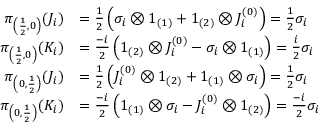<formula> <loc_0><loc_0><loc_500><loc_500>{ \begin{array} { r l } { \pi _ { \left ( { \frac { 1 } { 2 } } , 0 \right ) } ( J _ { i } ) } & { = { \frac { 1 } { 2 } } \left ( \sigma _ { i } \otimes 1 _ { ( 1 ) } + 1 _ { ( 2 ) } \otimes J _ { i } ^ { ( 0 ) } \right ) = { \frac { 1 } { 2 } } \sigma _ { i } } \\ { \pi _ { \left ( { \frac { 1 } { 2 } } , 0 \right ) } ( K _ { i } ) } & { = { \frac { - i } { 2 } } \left ( 1 _ { ( 2 ) } \otimes J _ { i } ^ { ( 0 ) } - \sigma _ { i } \otimes 1 _ { ( 1 ) } \right ) = { \frac { i } { 2 } } \sigma _ { i } } \\ { \pi _ { \left ( 0 , { \frac { 1 } { 2 } } \right ) } ( J _ { i } ) } & { = { \frac { 1 } { 2 } } \left ( J _ { i } ^ { ( 0 ) } \otimes 1 _ { ( 2 ) } + 1 _ { ( 1 ) } \otimes \sigma _ { i } \right ) = { \frac { 1 } { 2 } } \sigma _ { i } } \\ { \pi _ { \left ( 0 , { \frac { 1 } { 2 } } \right ) } ( K _ { i } ) } & { = { \frac { - i } { 2 } } \left ( 1 _ { ( 1 ) } \otimes \sigma _ { i } - J _ { i } ^ { ( 0 ) } \otimes 1 _ { ( 2 ) } \right ) = { \frac { - i } { 2 } } \sigma _ { i } } \end{array} }</formula> 